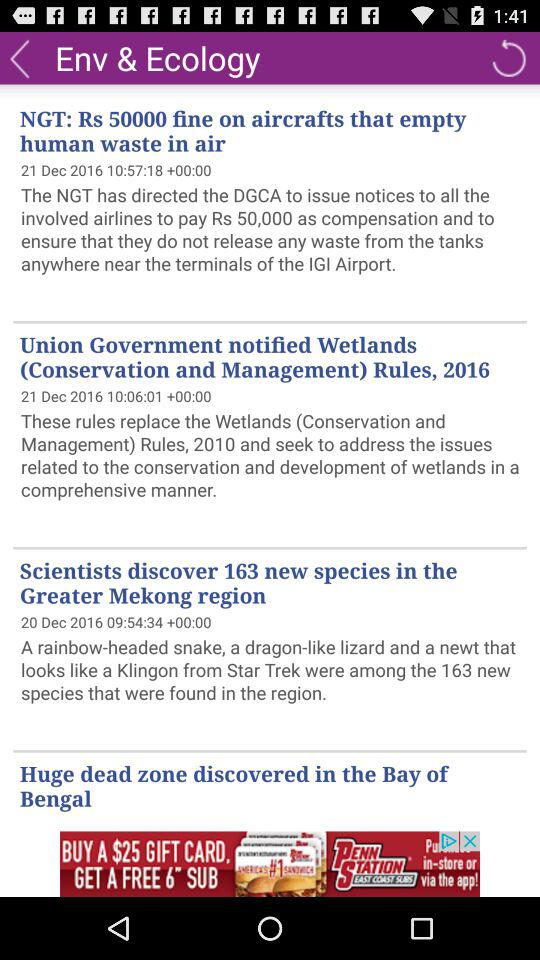How many new species were discovered by scientists? There were 163 new species discovered by scientists. 